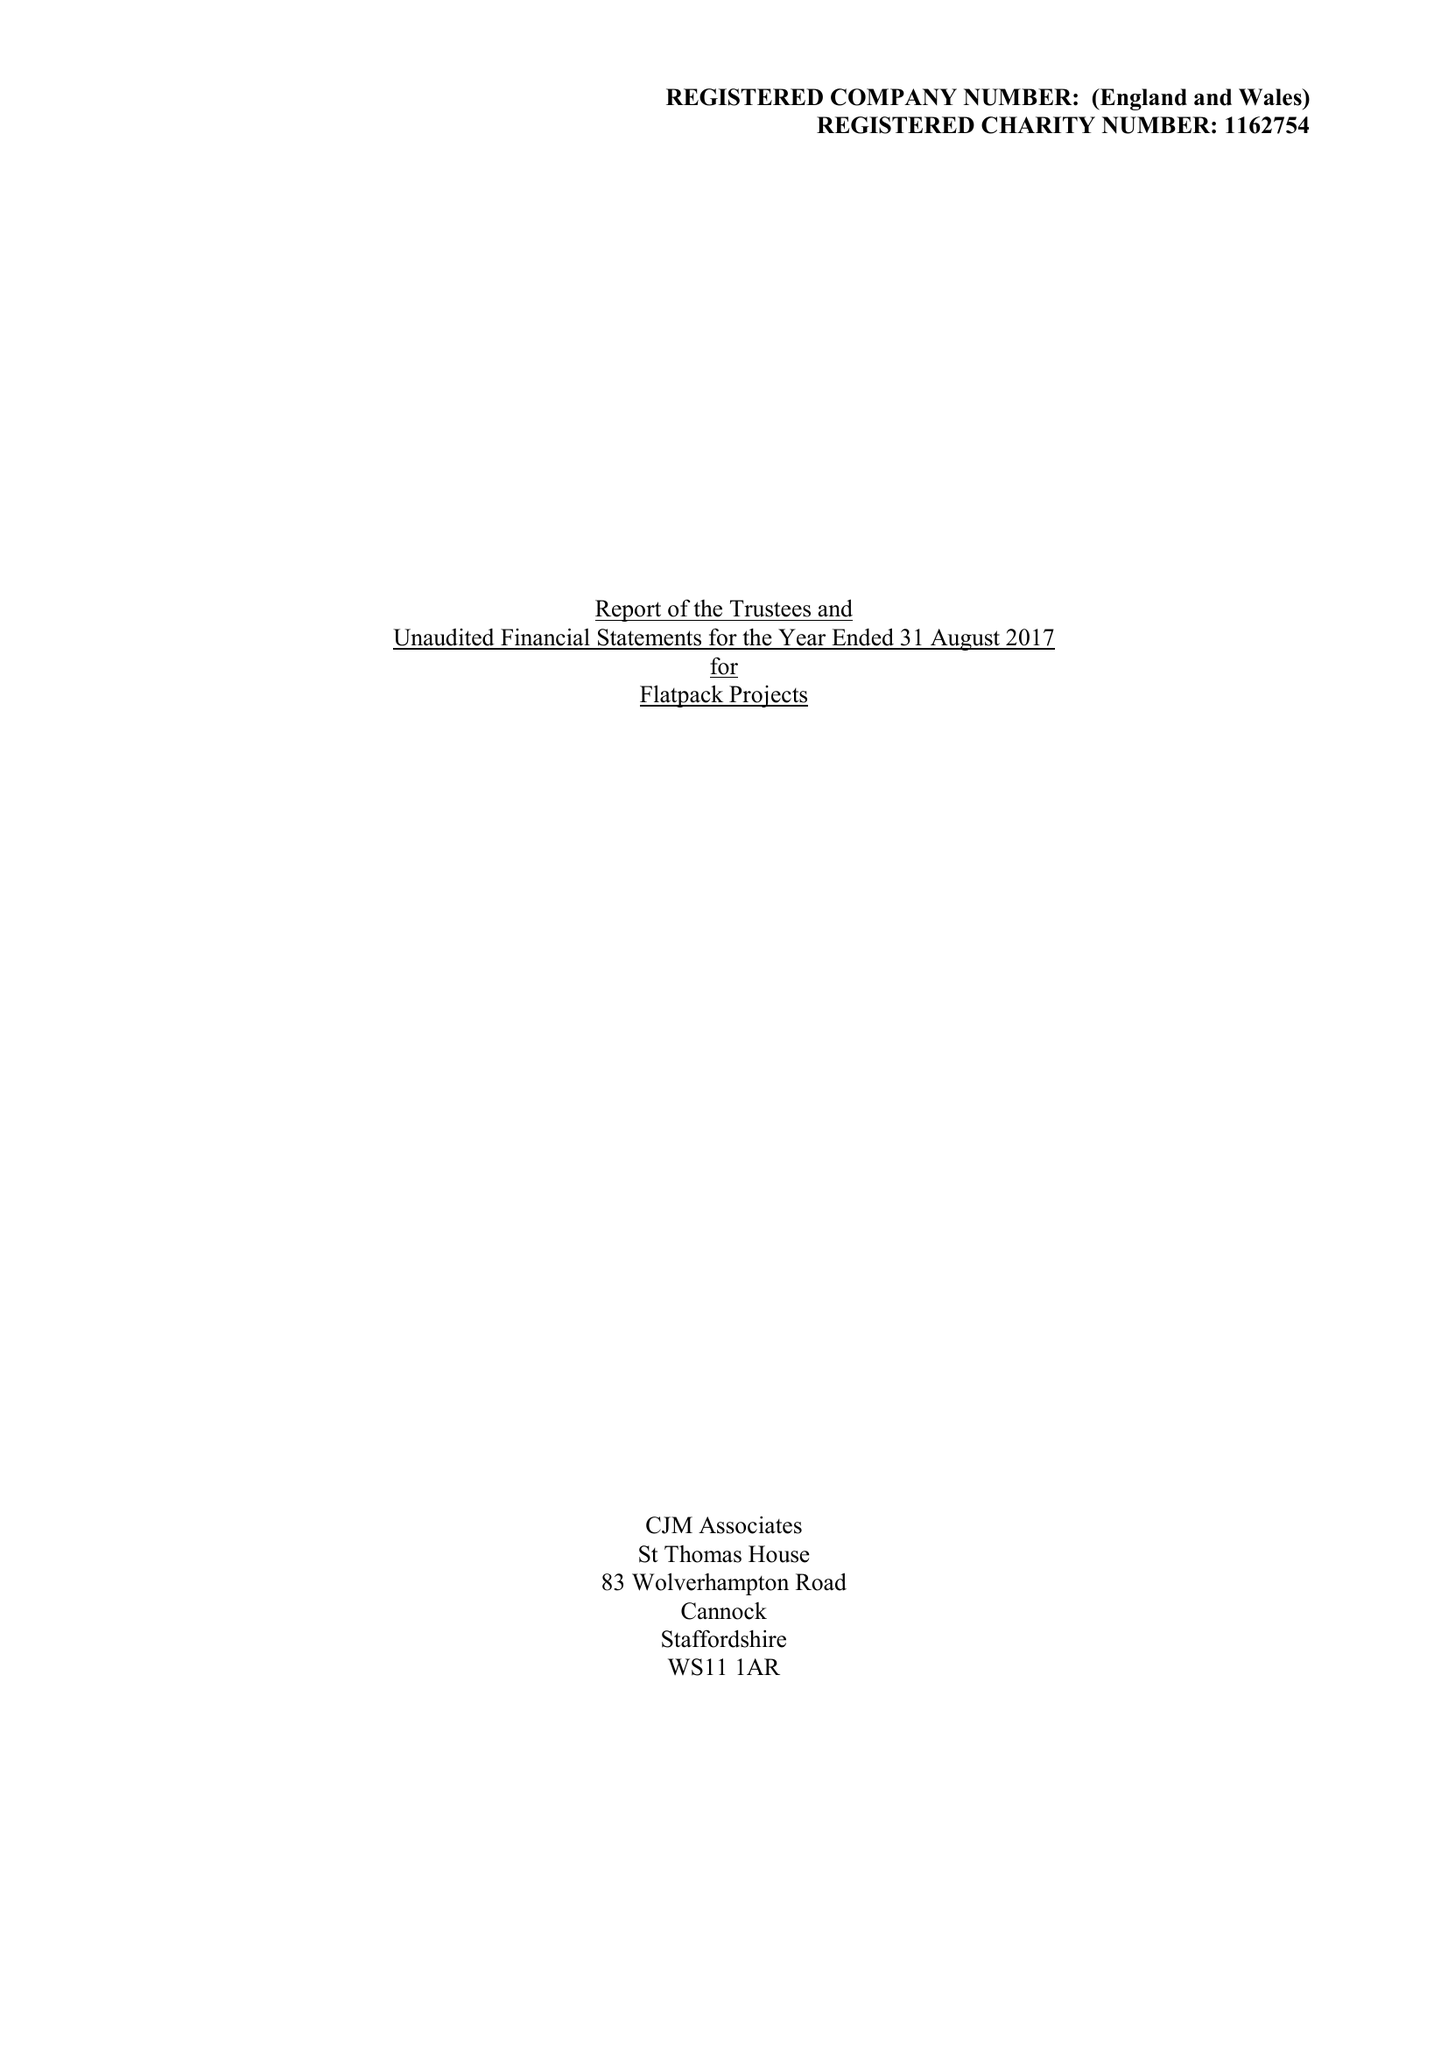What is the value for the address__post_town?
Answer the question using a single word or phrase. BIRMINGHAM 